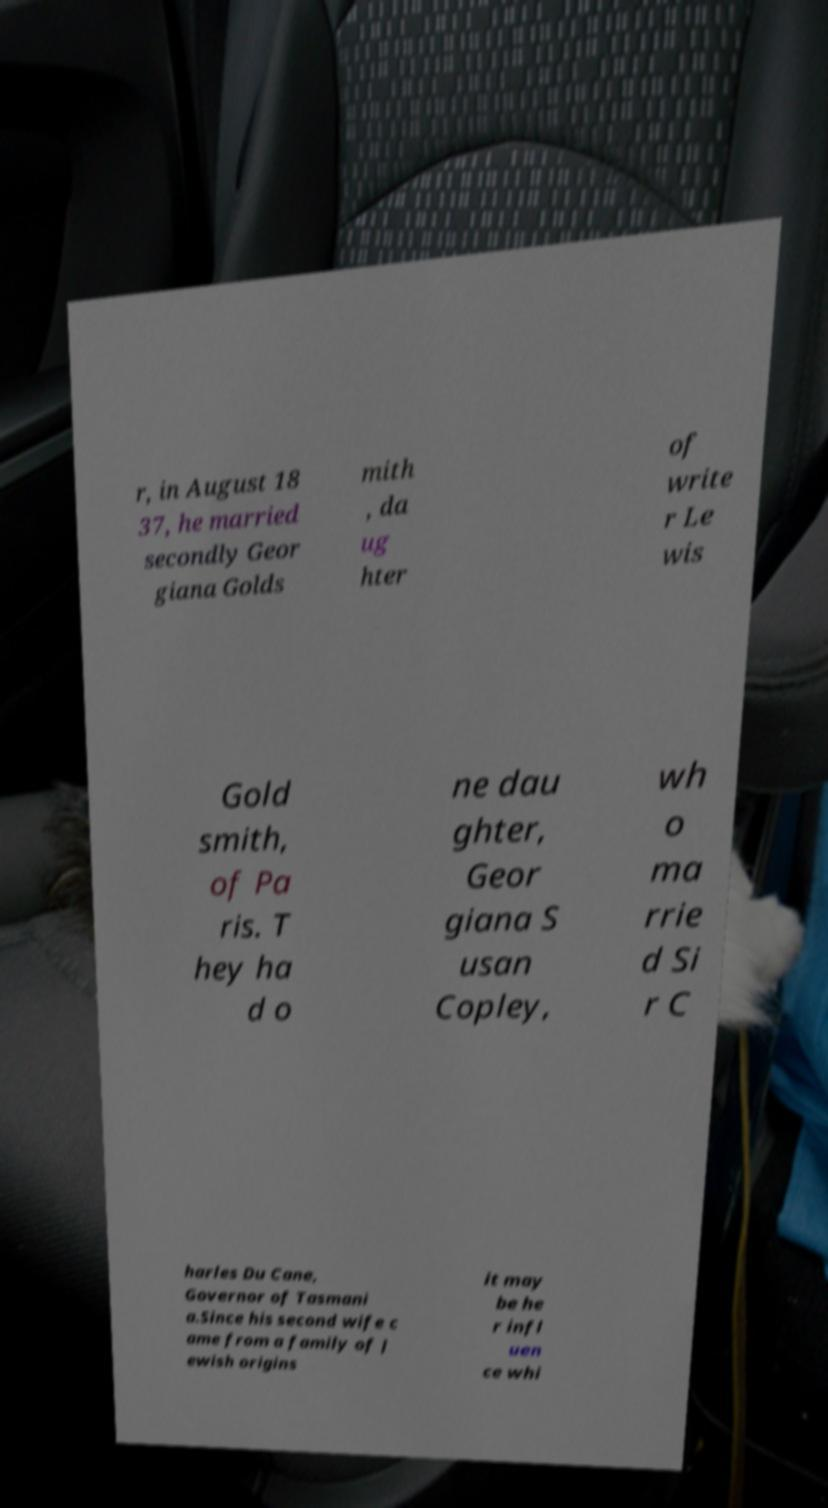Can you read and provide the text displayed in the image?This photo seems to have some interesting text. Can you extract and type it out for me? r, in August 18 37, he married secondly Geor giana Golds mith , da ug hter of write r Le wis Gold smith, of Pa ris. T hey ha d o ne dau ghter, Geor giana S usan Copley, wh o ma rrie d Si r C harles Du Cane, Governor of Tasmani a.Since his second wife c ame from a family of J ewish origins it may be he r infl uen ce whi 